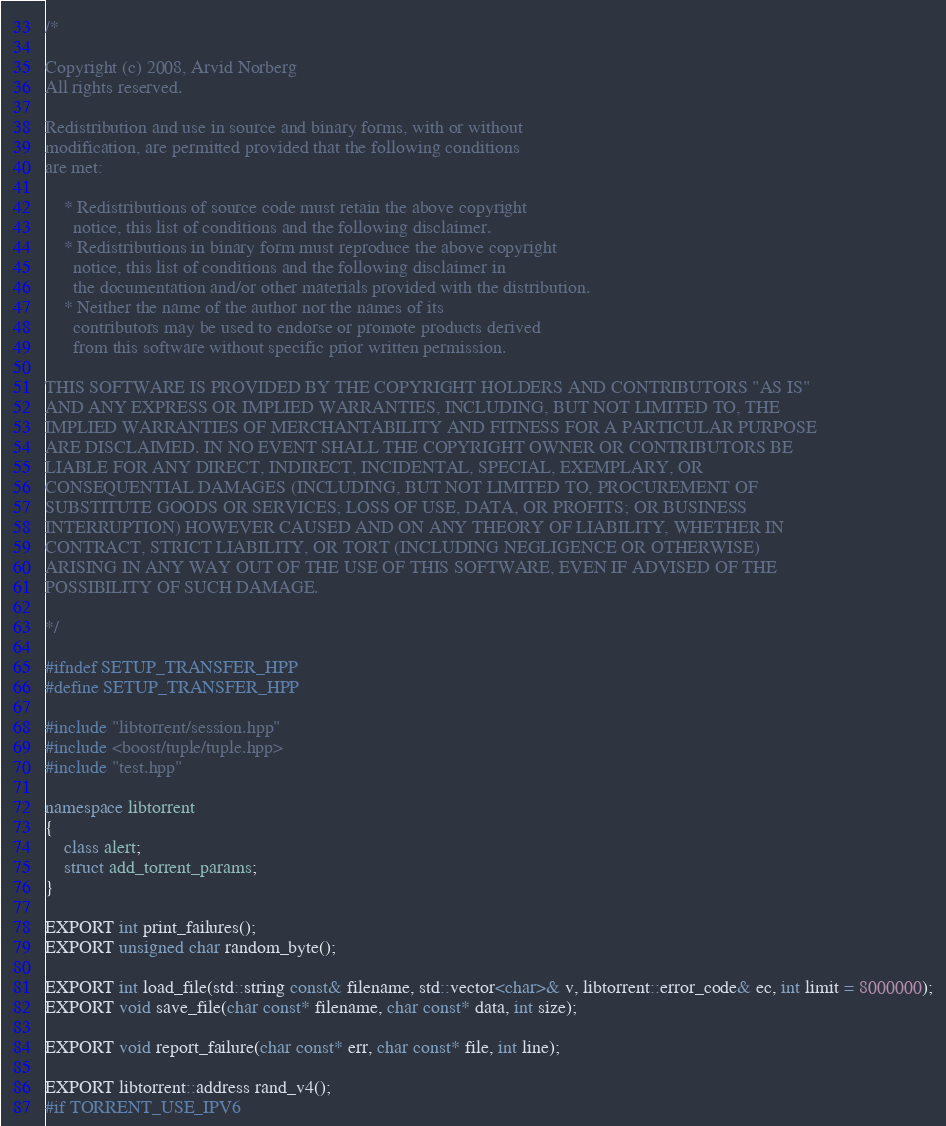<code> <loc_0><loc_0><loc_500><loc_500><_C++_>/*

Copyright (c) 2008, Arvid Norberg
All rights reserved.

Redistribution and use in source and binary forms, with or without
modification, are permitted provided that the following conditions
are met:

    * Redistributions of source code must retain the above copyright
      notice, this list of conditions and the following disclaimer.
    * Redistributions in binary form must reproduce the above copyright
      notice, this list of conditions and the following disclaimer in
      the documentation and/or other materials provided with the distribution.
    * Neither the name of the author nor the names of its
      contributors may be used to endorse or promote products derived
      from this software without specific prior written permission.

THIS SOFTWARE IS PROVIDED BY THE COPYRIGHT HOLDERS AND CONTRIBUTORS "AS IS"
AND ANY EXPRESS OR IMPLIED WARRANTIES, INCLUDING, BUT NOT LIMITED TO, THE
IMPLIED WARRANTIES OF MERCHANTABILITY AND FITNESS FOR A PARTICULAR PURPOSE
ARE DISCLAIMED. IN NO EVENT SHALL THE COPYRIGHT OWNER OR CONTRIBUTORS BE
LIABLE FOR ANY DIRECT, INDIRECT, INCIDENTAL, SPECIAL, EXEMPLARY, OR
CONSEQUENTIAL DAMAGES (INCLUDING, BUT NOT LIMITED TO, PROCUREMENT OF
SUBSTITUTE GOODS OR SERVICES; LOSS OF USE, DATA, OR PROFITS; OR BUSINESS
INTERRUPTION) HOWEVER CAUSED AND ON ANY THEORY OF LIABILITY, WHETHER IN
CONTRACT, STRICT LIABILITY, OR TORT (INCLUDING NEGLIGENCE OR OTHERWISE)
ARISING IN ANY WAY OUT OF THE USE OF THIS SOFTWARE, EVEN IF ADVISED OF THE
POSSIBILITY OF SUCH DAMAGE.

*/

#ifndef SETUP_TRANSFER_HPP
#define SETUP_TRANSFER_HPP

#include "libtorrent/session.hpp"
#include <boost/tuple/tuple.hpp>
#include "test.hpp"

namespace libtorrent
{
	class alert;
	struct add_torrent_params;
}

EXPORT int print_failures();
EXPORT unsigned char random_byte();

EXPORT int load_file(std::string const& filename, std::vector<char>& v, libtorrent::error_code& ec, int limit = 8000000);
EXPORT void save_file(char const* filename, char const* data, int size);

EXPORT void report_failure(char const* err, char const* file, int line);

EXPORT libtorrent::address rand_v4();
#if TORRENT_USE_IPV6</code> 